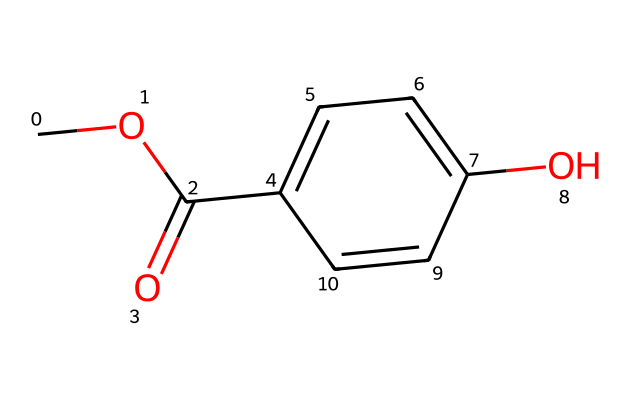How many carbon atoms are present in this chemical structure? The SMILES representation indicates a structure with several carbon atoms. Count the number of 'C' characters in the SMILES: there are six carbon atoms present.
Answer: six What functional group is represented in the chemical structure? The chemical has a 'COC(=O)' fragment, indicating the presence of an ester group; specifically, the presence of 'C(=O)' denotes a carbonyl group, which is characteristic of esters.
Answer: ester How many oxygen atoms are found in this chemical? The SMILES structure shows two 'O' characters: one in the ester (C(=O)) and the other as the ether (COC). Thus, there are two oxygen atoms present in total.
Answer: two Which part of the chemical structure indicates its preservative function? The presence of the ester and phenolic hydroxyl groups suggests it can function as a preservative; specifically, the hydroxyl group (-OH) can help in antimicrobial activity, which is essential for preservatives.
Answer: hydroxyl group What is the overall molecular weight (in g/mol) of this compound? To determine the molecular weight, sum the atomic weights of all constituent atoms based on the SMILES: C (6 x 12.01), H (6 x 1.008), O (2 x 16.00). This calculation gives a total of approximately 138.16 g/mol.
Answer: 138.16 Is this structure symmetric in any way? Analyzing the structure, it shows a plane of symmetry through the aromatic ring; however, the presence of different functional groups leads to asymmetry overall. Therefore, the compound has some symmetric properties but is not fully symmetric.
Answer: partially symmetric What type of aromatic ring is present in this chemical? The chemical shows a phenolic structure with a hydroxyl group (-OH) attached to it, suggesting it has a simple aromatic ring made entirely of carbon, specifically a benzene ring.
Answer: benzene ring 